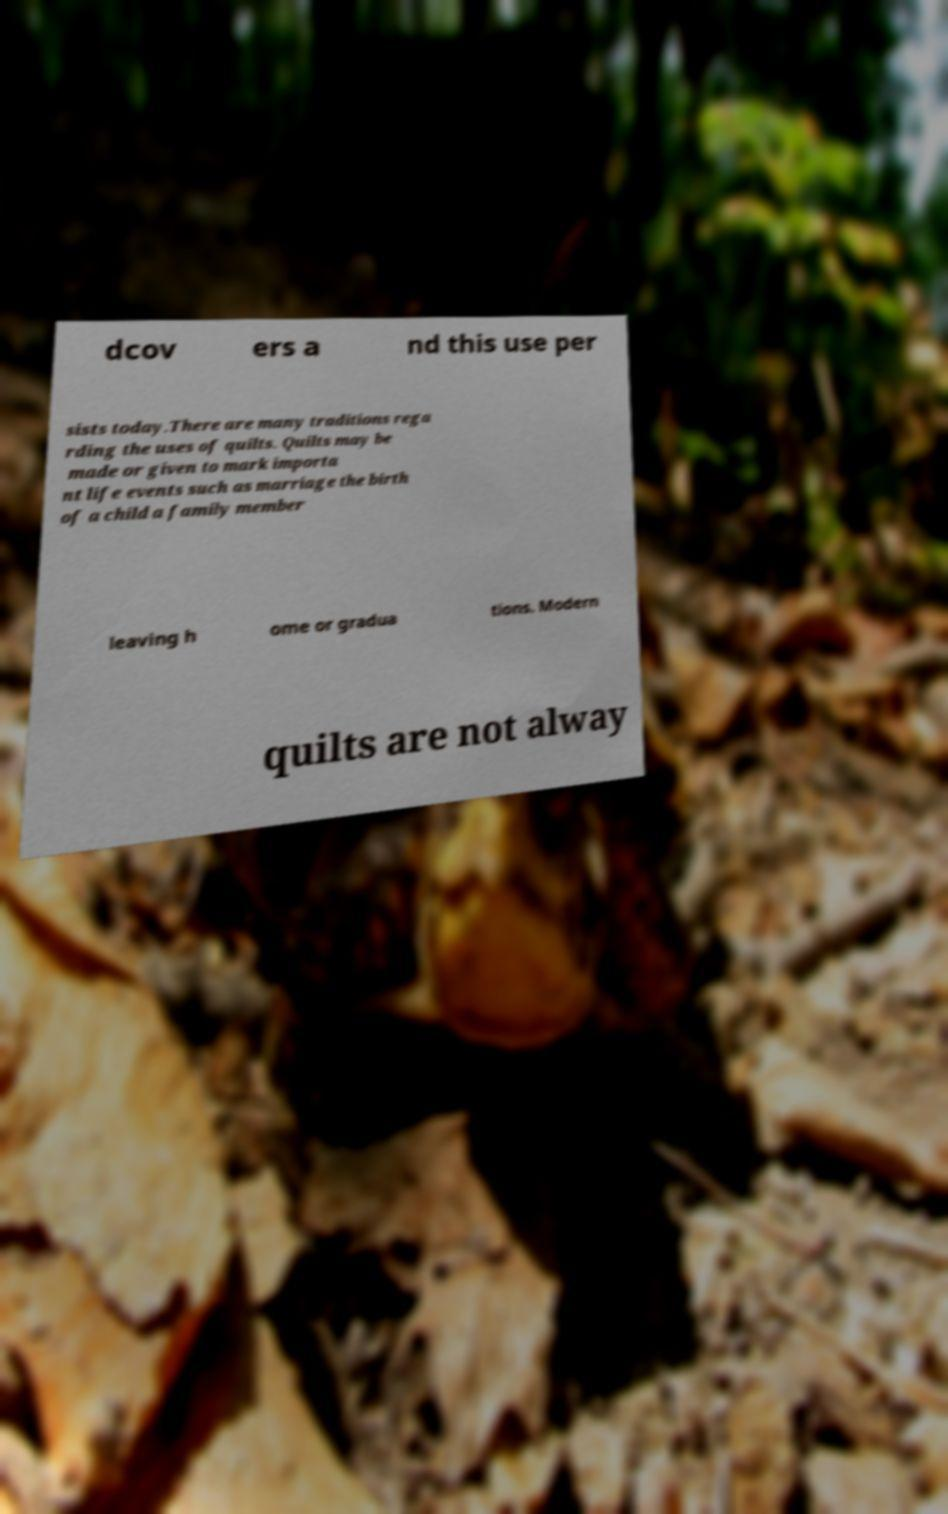There's text embedded in this image that I need extracted. Can you transcribe it verbatim? dcov ers a nd this use per sists today.There are many traditions rega rding the uses of quilts. Quilts may be made or given to mark importa nt life events such as marriage the birth of a child a family member leaving h ome or gradua tions. Modern quilts are not alway 